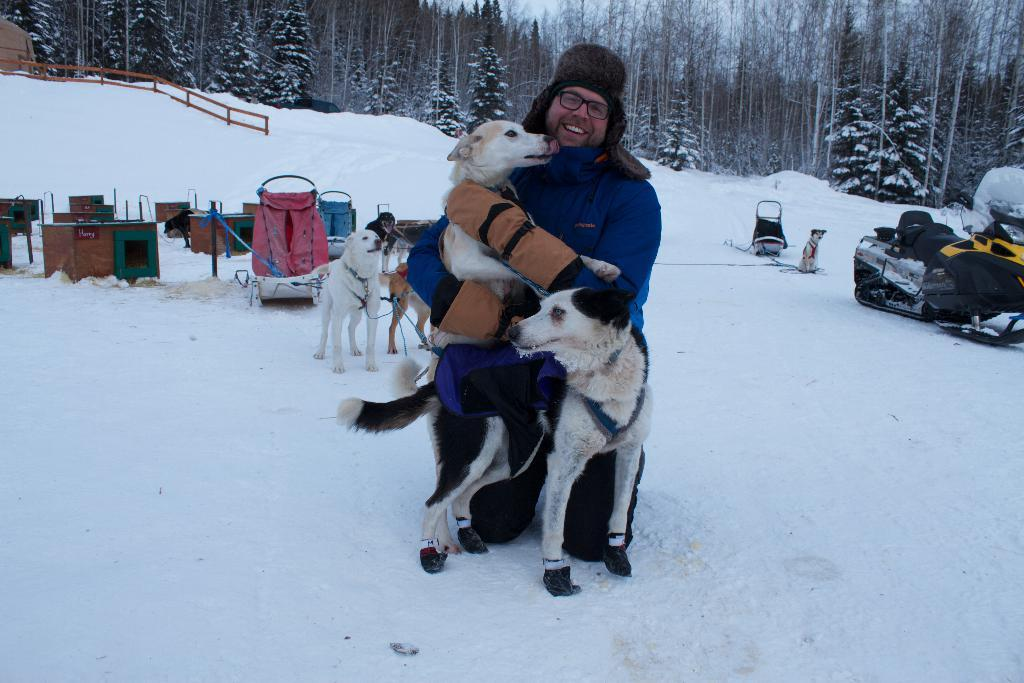Who or what can be seen in the image? There is a person and dogs in the image. What is the person doing in the image? The person's actions are not specified, but they are present in the image. What type of vehicle is in the image? There is a vehicle in the image, but its specific type is not mentioned. What is the weather like in the image? There is snow in the image, indicating a cold or wintry environment. What is the background of the image like? There is a fence, trees, and the sky visible in the background of the image. What type of haircut does the committee recommend for the person in the image? There is no mention of a committee or a haircut in the image, so this question cannot be answered. 